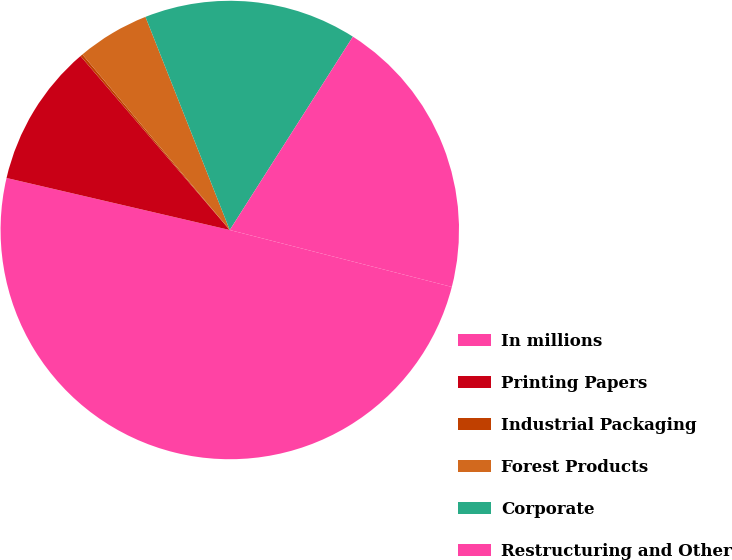<chart> <loc_0><loc_0><loc_500><loc_500><pie_chart><fcel>In millions<fcel>Printing Papers<fcel>Industrial Packaging<fcel>Forest Products<fcel>Corporate<fcel>Restructuring and Other<nl><fcel>49.65%<fcel>10.07%<fcel>0.17%<fcel>5.12%<fcel>15.02%<fcel>19.97%<nl></chart> 